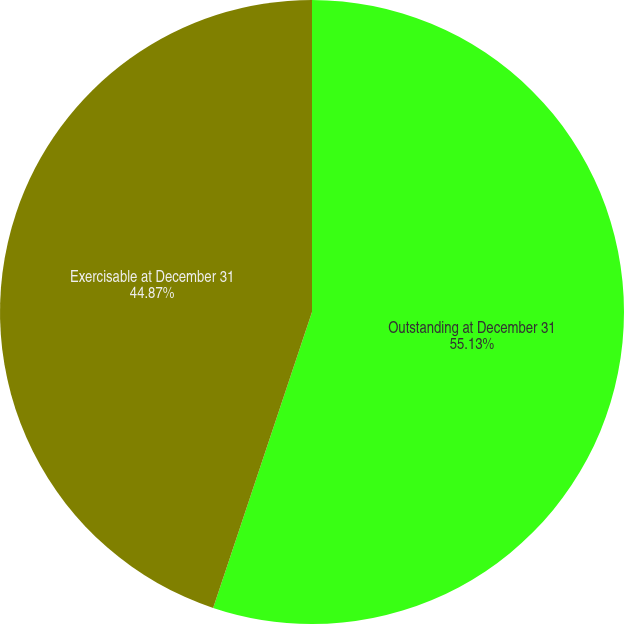Convert chart to OTSL. <chart><loc_0><loc_0><loc_500><loc_500><pie_chart><fcel>Outstanding at December 31<fcel>Exercisable at December 31<nl><fcel>55.13%<fcel>44.87%<nl></chart> 